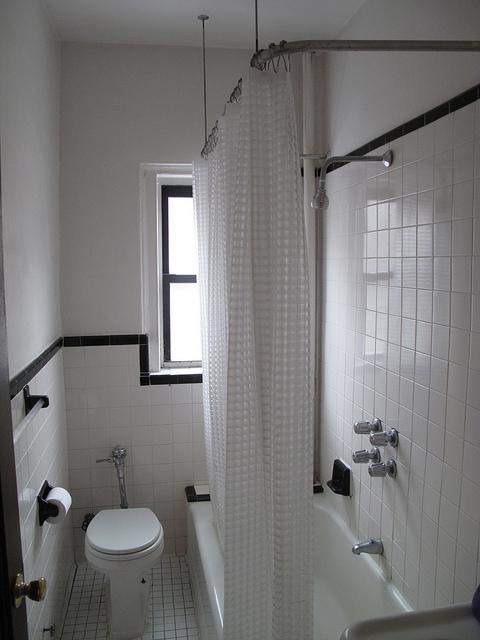Was the shower curtain ironed?
Quick response, please. No. Does the toilet have a tank on the back of it?
Write a very short answer. No. What color is the shower curtain?
Answer briefly. White. Is the shower curtain open?
Write a very short answer. Yes. Is this a large bathroom?
Short answer required. No. What color are the stripes on the wall?
Quick response, please. Black. 